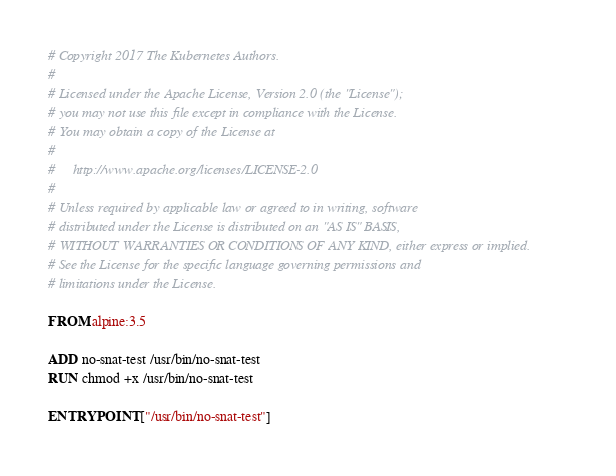Convert code to text. <code><loc_0><loc_0><loc_500><loc_500><_Dockerfile_># Copyright 2017 The Kubernetes Authors.
#
# Licensed under the Apache License, Version 2.0 (the "License");
# you may not use this file except in compliance with the License.
# You may obtain a copy of the License at
#
#     http://www.apache.org/licenses/LICENSE-2.0
#
# Unless required by applicable law or agreed to in writing, software
# distributed under the License is distributed on an "AS IS" BASIS,
# WITHOUT WARRANTIES OR CONDITIONS OF ANY KIND, either express or implied.
# See the License for the specific language governing permissions and
# limitations under the License.

FROM alpine:3.5

ADD no-snat-test /usr/bin/no-snat-test
RUN chmod +x /usr/bin/no-snat-test

ENTRYPOINT ["/usr/bin/no-snat-test"]</code> 